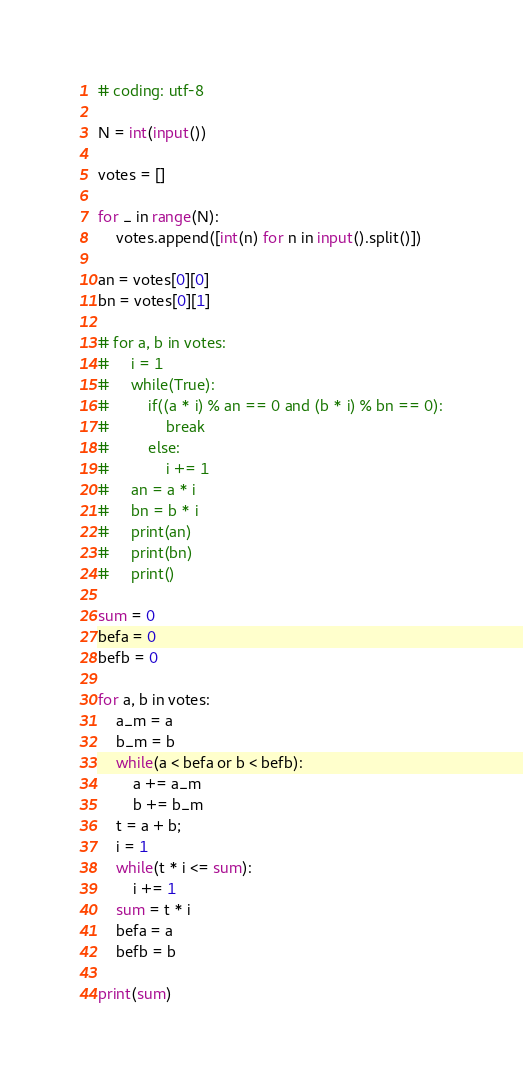Convert code to text. <code><loc_0><loc_0><loc_500><loc_500><_Python_># coding: utf-8

N = int(input())

votes = []

for _ in range(N):
    votes.append([int(n) for n in input().split()])

an = votes[0][0]
bn = votes[0][1]

# for a, b in votes:
#     i = 1
#     while(True):
#         if((a * i) % an == 0 and (b * i) % bn == 0):
#             break
#         else:
#             i += 1
#     an = a * i
#     bn = b * i
#     print(an)
#     print(bn)
#     print()

sum = 0
befa = 0
befb = 0

for a, b in votes:
    a_m = a
    b_m = b
    while(a < befa or b < befb):
        a += a_m
        b += b_m
    t = a + b;
    i = 1
    while(t * i <= sum):
        i += 1
    sum = t * i
    befa = a
    befb = b

print(sum)

</code> 